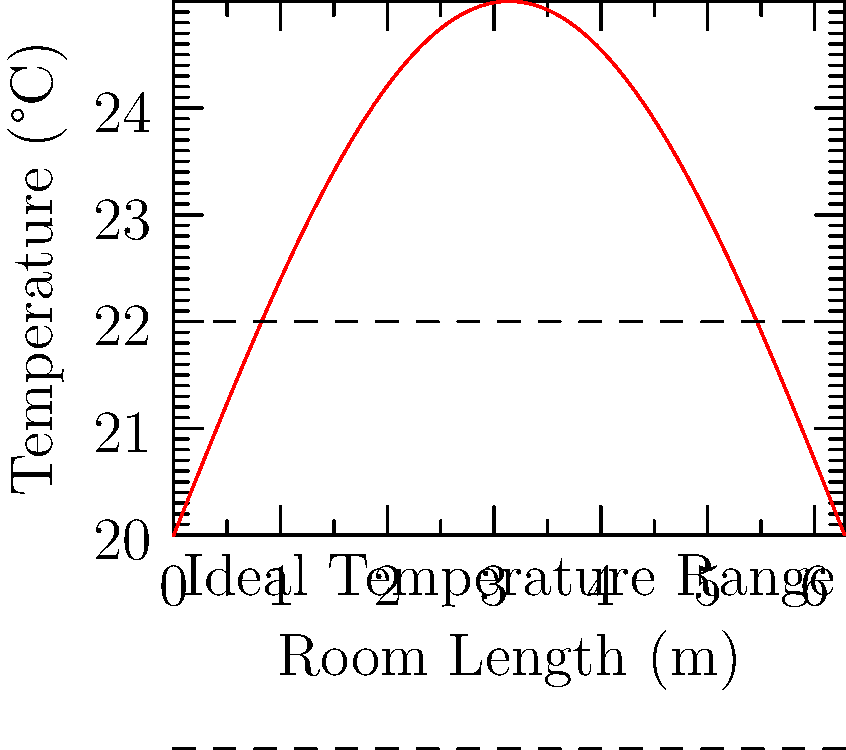Analyze the temperature gradient in a puppy living space as shown in the graph. What is the approximate wavelength of the temperature fluctuation across the room length, and how does this relate to creating optimal thermal zones for puppies? To answer this question, let's follow these steps:

1. Observe the graph: The temperature varies sinusoidally across the room length.

2. Identify key features:
   - The x-axis represents room length in meters.
   - The y-axis shows temperature in degrees Celsius.
   - The red curve represents the temperature gradient.

3. Calculate the wavelength:
   - One complete cycle (wavelength) spans the entire x-axis.
   - The x-axis goes from 0 to approximately 6.28 meters.
   - Therefore, the wavelength is about 6.28 meters (which is $2\pi$).

4. Analyze thermal zones:
   - The graph shows alternating warmer and cooler areas.
   - Optimal temperature is around 20°C (middle of the curve).
   - Warmer zones reach about 24°C, cooler zones about 16°C.

5. Relate to puppy care:
   - This gradient creates diverse thermal environments.
   - Puppies can self-regulate by moving to preferred temperature zones.
   - Warmer areas (peaks) are suitable for sleeping or resting.
   - Cooler areas (troughs) are good for active play or cooling down.

6. Consider the wavelength in room design:
   - With a 6.28m wavelength, there are distinct zones every ~3.14m (half-wavelength).
   - This allows for multiple thermal options in a reasonably sized room.

The wavelength of approximately 6.28m creates an ideal balance of thermal zones, allowing puppies to find comfortable areas for various activities and rest throughout the day.
Answer: Wavelength ≈ 6.28m; creates diverse thermal zones for puppy comfort and self-regulation. 